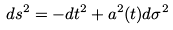Convert formula to latex. <formula><loc_0><loc_0><loc_500><loc_500>d s ^ { 2 } = - d t ^ { 2 } + a ^ { 2 } ( t ) d \sigma ^ { 2 }</formula> 